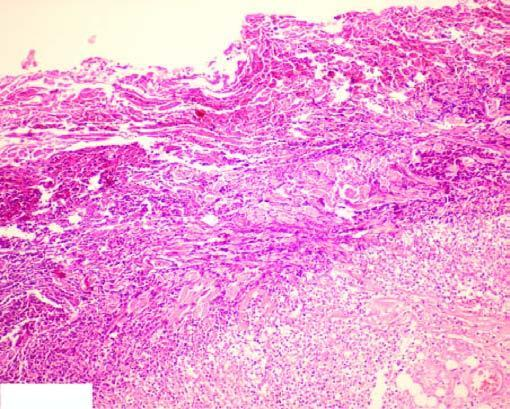where are some macrophages seen?
Answer the question using a single word or phrase. At the periphery 